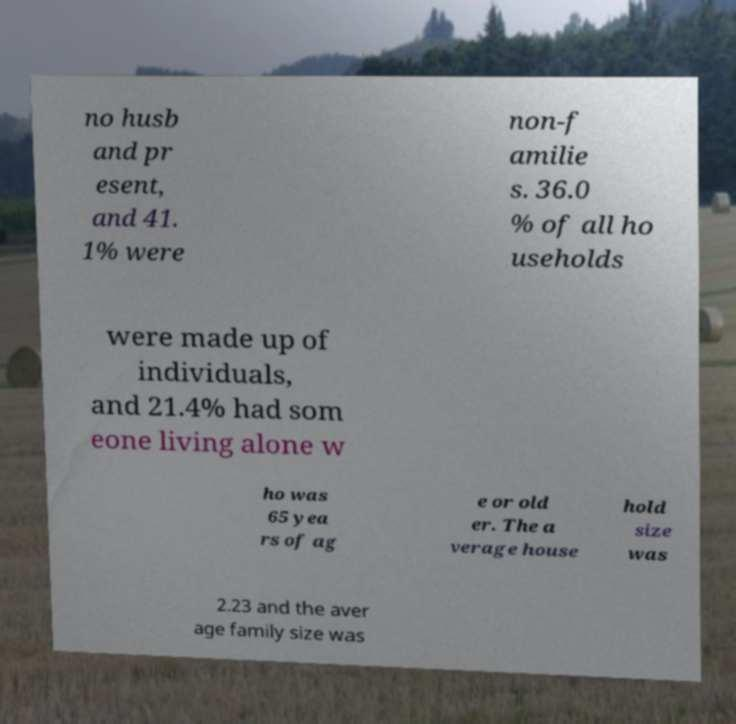Please read and relay the text visible in this image. What does it say? no husb and pr esent, and 41. 1% were non-f amilie s. 36.0 % of all ho useholds were made up of individuals, and 21.4% had som eone living alone w ho was 65 yea rs of ag e or old er. The a verage house hold size was 2.23 and the aver age family size was 